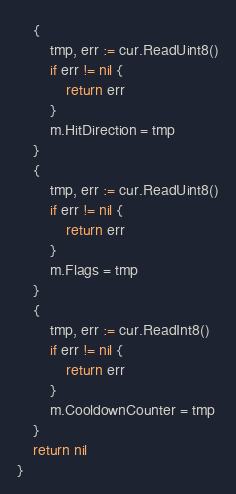Convert code to text. <code><loc_0><loc_0><loc_500><loc_500><_Go_>	{
		tmp, err := cur.ReadUint8()
		if err != nil {
			return err
		}
		m.HitDirection = tmp
	}
	{
		tmp, err := cur.ReadUint8()
		if err != nil {
			return err
		}
		m.Flags = tmp
	}
	{
		tmp, err := cur.ReadInt8()
		if err != nil {
			return err
		}
		m.CooldownCounter = tmp
	}
	return nil
}
</code> 